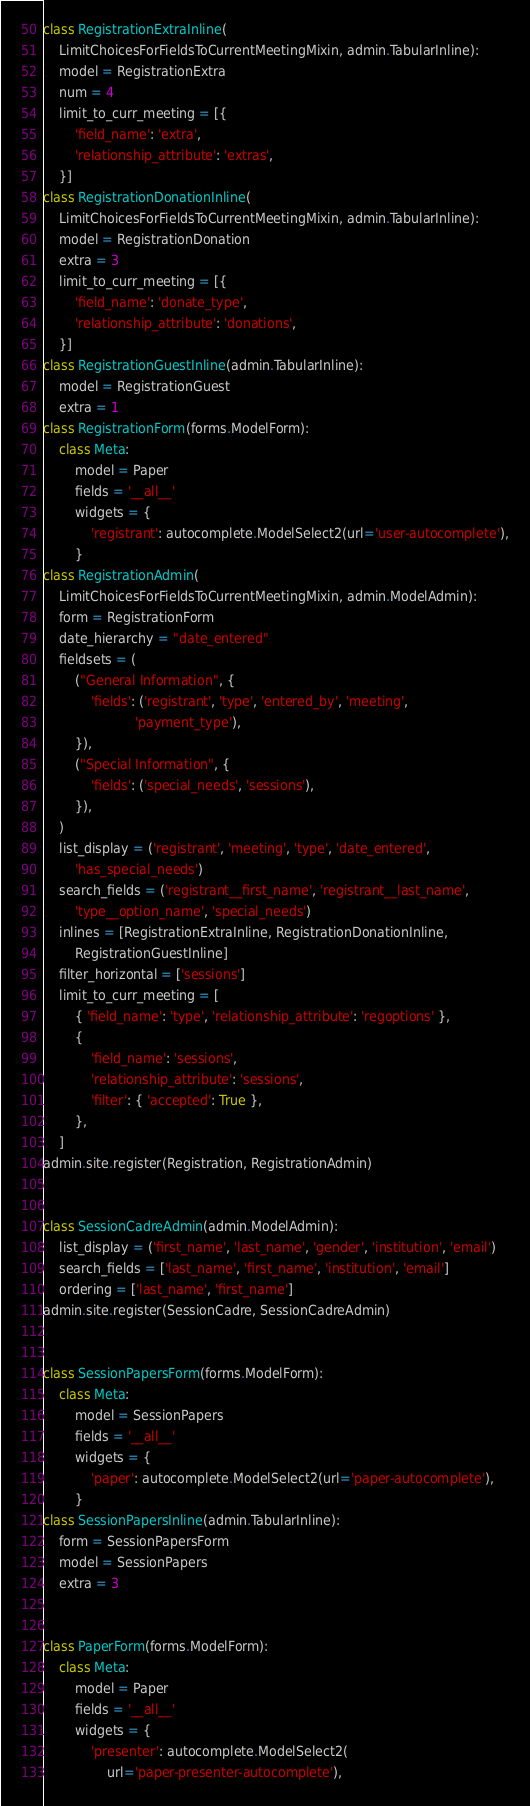<code> <loc_0><loc_0><loc_500><loc_500><_Python_>
class RegistrationExtraInline(
    LimitChoicesForFieldsToCurrentMeetingMixin, admin.TabularInline):
    model = RegistrationExtra
    num = 4
    limit_to_curr_meeting = [{
        'field_name': 'extra',
        'relationship_attribute': 'extras',
    }]
class RegistrationDonationInline(
    LimitChoicesForFieldsToCurrentMeetingMixin, admin.TabularInline):
    model = RegistrationDonation
    extra = 3
    limit_to_curr_meeting = [{
        'field_name': 'donate_type',
        'relationship_attribute': 'donations',
    }]
class RegistrationGuestInline(admin.TabularInline):
    model = RegistrationGuest
    extra = 1
class RegistrationForm(forms.ModelForm):
    class Meta:
        model = Paper
        fields = '__all__'
        widgets = {
            'registrant': autocomplete.ModelSelect2(url='user-autocomplete'),
        }
class RegistrationAdmin(
    LimitChoicesForFieldsToCurrentMeetingMixin, admin.ModelAdmin):
    form = RegistrationForm
    date_hierarchy = "date_entered"
    fieldsets = (
        ("General Information", {
            'fields': ('registrant', 'type', 'entered_by', 'meeting',
                       'payment_type'),
        }),
        ("Special Information", {
            'fields': ('special_needs', 'sessions'),
        }),
    )
    list_display = ('registrant', 'meeting', 'type', 'date_entered',
        'has_special_needs')
    search_fields = ('registrant__first_name', 'registrant__last_name',
        'type__option_name', 'special_needs')
    inlines = [RegistrationExtraInline, RegistrationDonationInline,
        RegistrationGuestInline]
    filter_horizontal = ['sessions']
    limit_to_curr_meeting = [
        { 'field_name': 'type', 'relationship_attribute': 'regoptions' },
        {
            'field_name': 'sessions',
            'relationship_attribute': 'sessions',
            'filter': { 'accepted': True },
        },
    ]
admin.site.register(Registration, RegistrationAdmin)


class SessionCadreAdmin(admin.ModelAdmin):
    list_display = ('first_name', 'last_name', 'gender', 'institution', 'email')
    search_fields = ['last_name', 'first_name', 'institution', 'email']
    ordering = ['last_name', 'first_name']
admin.site.register(SessionCadre, SessionCadreAdmin)


class SessionPapersForm(forms.ModelForm):
    class Meta:
        model = SessionPapers
        fields = '__all__'
        widgets = {
            'paper': autocomplete.ModelSelect2(url='paper-autocomplete'),
        }
class SessionPapersInline(admin.TabularInline):
    form = SessionPapersForm
    model = SessionPapers
    extra = 3


class PaperForm(forms.ModelForm):
    class Meta:
        model = Paper
        fields = '__all__'
        widgets = {
            'presenter': autocomplete.ModelSelect2(
                url='paper-presenter-autocomplete'),</code> 